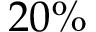Convert formula to latex. <formula><loc_0><loc_0><loc_500><loc_500>2 0 \%</formula> 